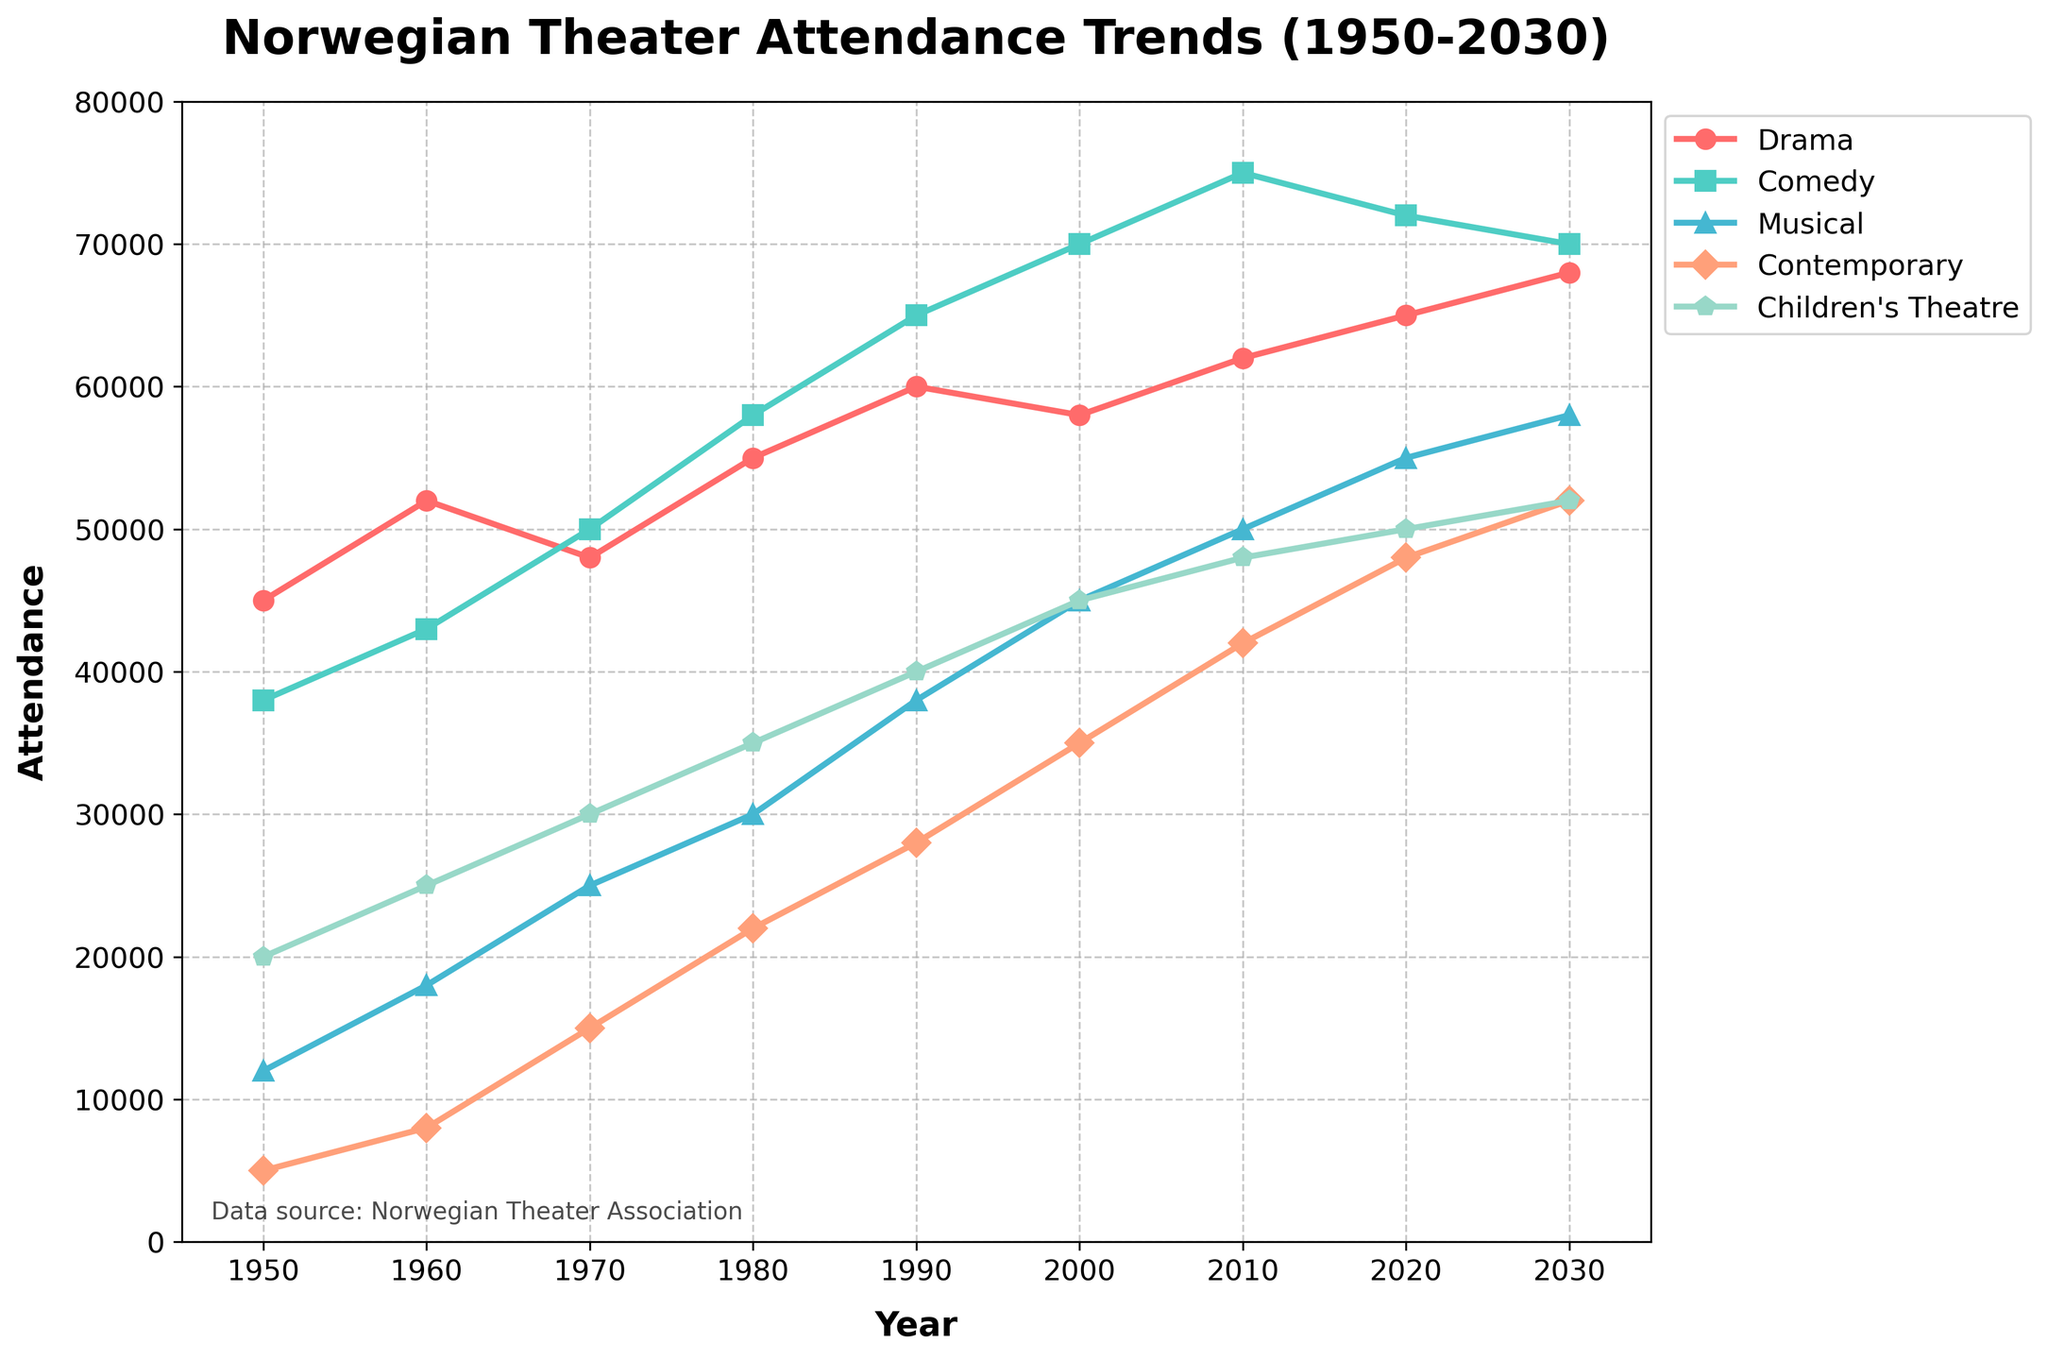How has the attendance for Musicals changed from 1950 to 2000? In 1950, the attendance for Musicals was 12,000. By 2000, it had grown to 45,000. To find the difference, subtract the 1950 attendance from the 2000 attendance: 45,000 - 12,000 = 33,000. Therefore, the attendance for Musicals increased by 33,000 from 1950 to 2000.
Answer: Increased by 33,000 Which genre experienced the highest growth in attendance from 1950 to 2030? By comparing the attendance in 1950 and 2030 for each genre: Drama (68,000 - 45,000 = 23,000), Comedy (70,000 - 38,000 = 32,000), Musical (58,000 - 12,000 = 46,000), Contemporary (52,000 - 5,000 = 47,000), and Children’s Theatre (52,000 - 20,000 = 32,000). Contemporary showed the highest growth of 47,000.
Answer: Contemporary In which year did Comedy attendance surpass Drama attendance? Looking at the trend lines, in 1970, Comedy attendance (50,000) surpasses Drama attendance (48,000) for the first time.
Answer: 1970 What is the average attendance of Drama and Comedy in 1980? To find the average, add Drama (55,000) and Comedy (58,000) for 1980, then divide by 2. (55,000 + 58,000) / 2 = 113,000 / 2 = 56,500.
Answer: 56,500 Is the Children's Theatre attendance in 2020 higher, lower, or equal to the Musical attendance in 1970? Children's Theatre attendance in 2020 is 50,000, and Musical attendance in 1970 is 25,000. Therefore, 50,000 is greater than 25,000.
Answer: Higher Between 1950 and 2030, which genre had the smallest percentage increase in attendance? Calculate the percentage increase for each genre: Drama (23,000/45,000 ~ 51%), Comedy (32,000/38,000 ~ 84%), Musical (46,000/12,000 ~ 383%), Contemporary (47,000/5,000 ~ 940%), and Children's Theatre (32,000/20,000 ~ 160%). Drama has the smallest percentage increase (~51%).
Answer: Drama Which genre saw the biggest drop in attendance from 2010 to 2020? Looking at the data, we see: Drama (62,000 to 65,000), Comedy (75,000 to 72,000), Musical (50,000 to 55,000), Contemporary (42,000 to 48,000), Children’s Theatre (48,000 to 50,000). Comedy attendance drops by 3,000.
Answer: Comedy What is the total attendance for all genres in 1990? Sum all the attendance in 1990: Drama (60,000) + Comedy (65,000) + Musical (38,000) + Contemporary (28,000) + Children’s Theatre (40,000) = 231,000.
Answer: 231,000 How many genres have an attendance greater than 50,000 in 2030? In 2030, the attendance for Drama (68,000), Comedy (70,000), Musical (58,000), Contemporary (52,000), and Children’s Theatre (52,000). All five genres have an attendance greater than 50,000.
Answer: 5 What is the attendance difference between Contemporary and Children’s Theatre in 1980? Comparing Contemporary (22,000) and Children’s Theatre (35,000) in 1980: 35,000 - 22,000 = 13,000.
Answer: 13,000 